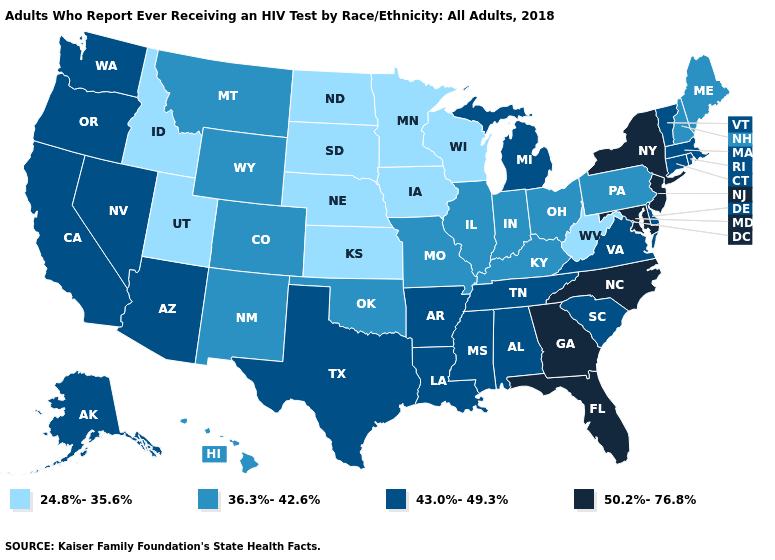Is the legend a continuous bar?
Give a very brief answer. No. Among the states that border South Dakota , does Iowa have the lowest value?
Give a very brief answer. Yes. What is the lowest value in the USA?
Write a very short answer. 24.8%-35.6%. Which states have the highest value in the USA?
Quick response, please. Florida, Georgia, Maryland, New Jersey, New York, North Carolina. Does Hawaii have the same value as Illinois?
Give a very brief answer. Yes. Which states have the highest value in the USA?
Be succinct. Florida, Georgia, Maryland, New Jersey, New York, North Carolina. How many symbols are there in the legend?
Concise answer only. 4. Does Rhode Island have a lower value than Michigan?
Answer briefly. No. What is the value of Oregon?
Give a very brief answer. 43.0%-49.3%. Among the states that border Missouri , does Kansas have the highest value?
Concise answer only. No. Does Hawaii have a higher value than Indiana?
Concise answer only. No. Name the states that have a value in the range 24.8%-35.6%?
Keep it brief. Idaho, Iowa, Kansas, Minnesota, Nebraska, North Dakota, South Dakota, Utah, West Virginia, Wisconsin. Does the map have missing data?
Answer briefly. No. What is the value of Washington?
Keep it brief. 43.0%-49.3%. Which states have the highest value in the USA?
Give a very brief answer. Florida, Georgia, Maryland, New Jersey, New York, North Carolina. 